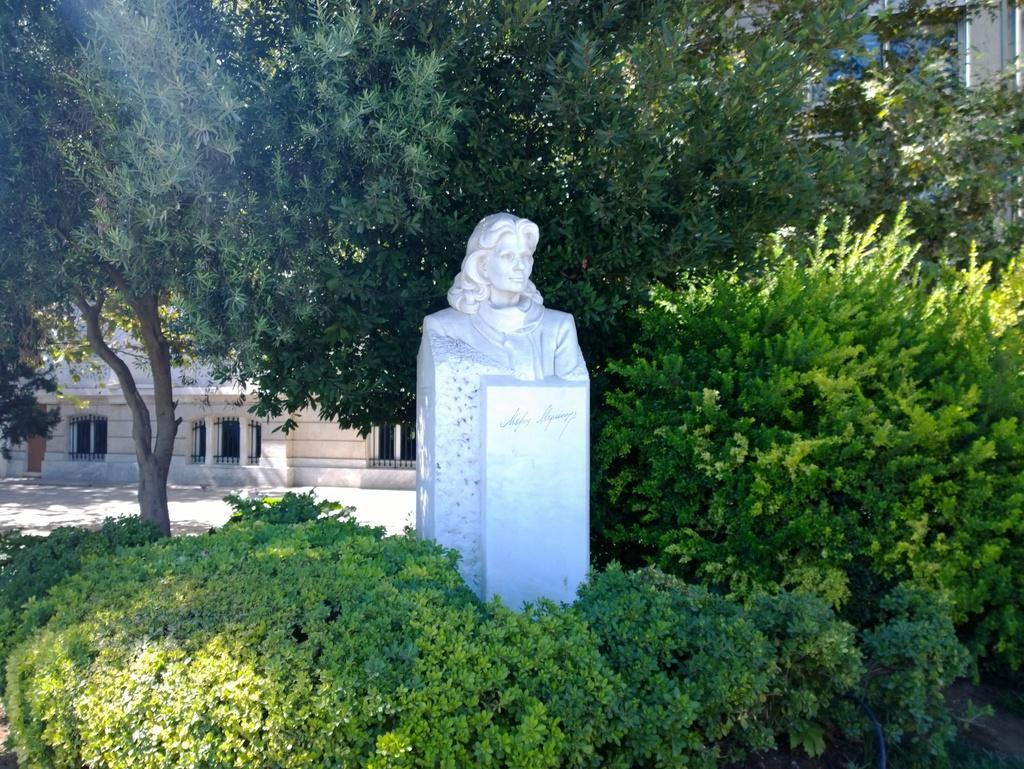What is the main subject of the image? There is a statue of a woman in the image. What can be seen in the background of the image? There are buildings in the background of the image. What type of natural elements are visible in the image? There are trees visible in the image. What type of beef is being served at the event in the image? There is no event or beef present in the image; it features a statue of a woman with buildings and trees in the background. 